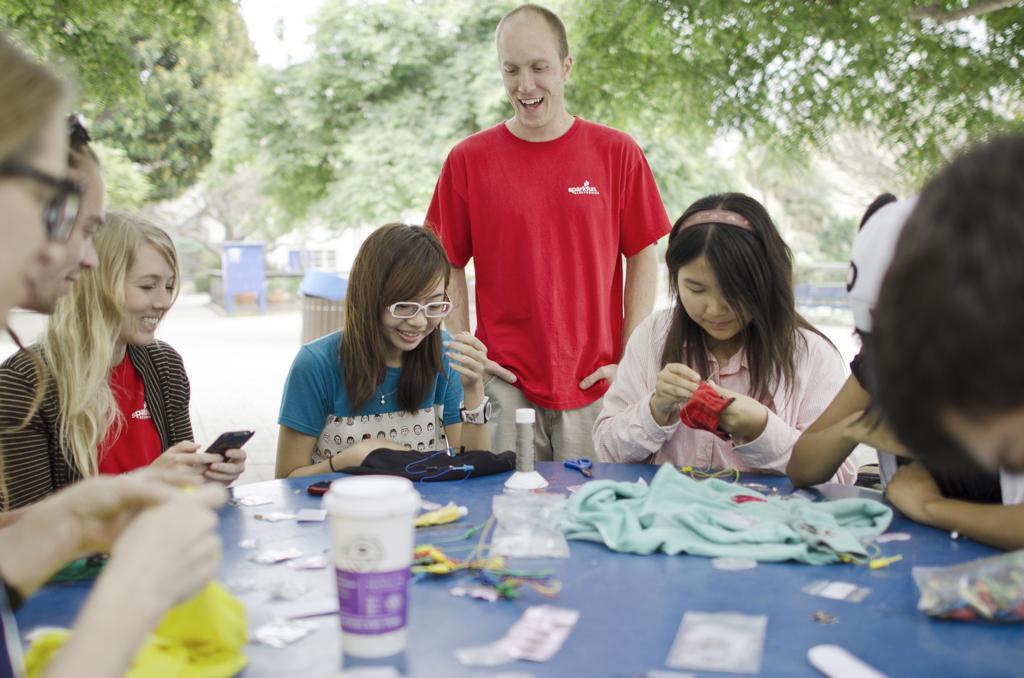Can you describe this image briefly? There are many people sitting around a table. On the right lady wearing a pink dress is doing a craft. Behind her a person wearing a red t shirt is standing. Also a girl wearing a blue t shirt, specs and watch. On the right a woman is holding a mobile. On the table there are bottles, clothes and many other item. In the background there are trees and boxes. 